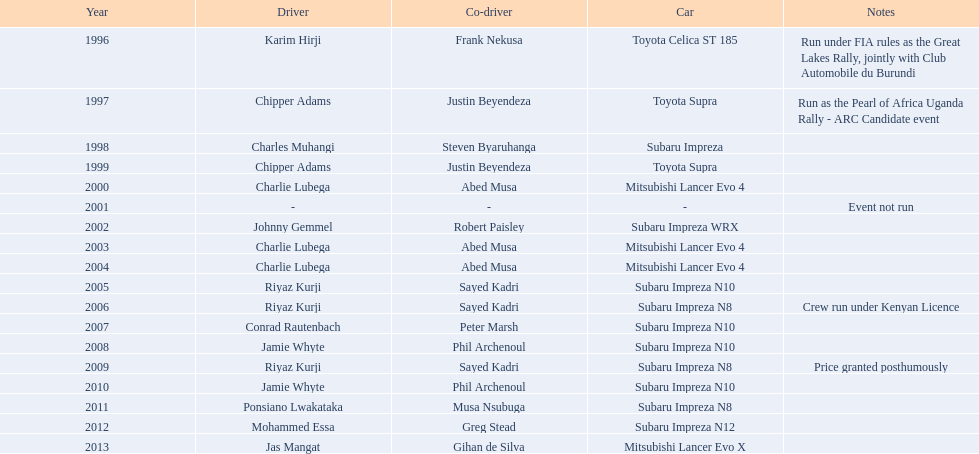Who was the driver that claimed victory following ponsiano lwakataka? Mohammed Essa. 